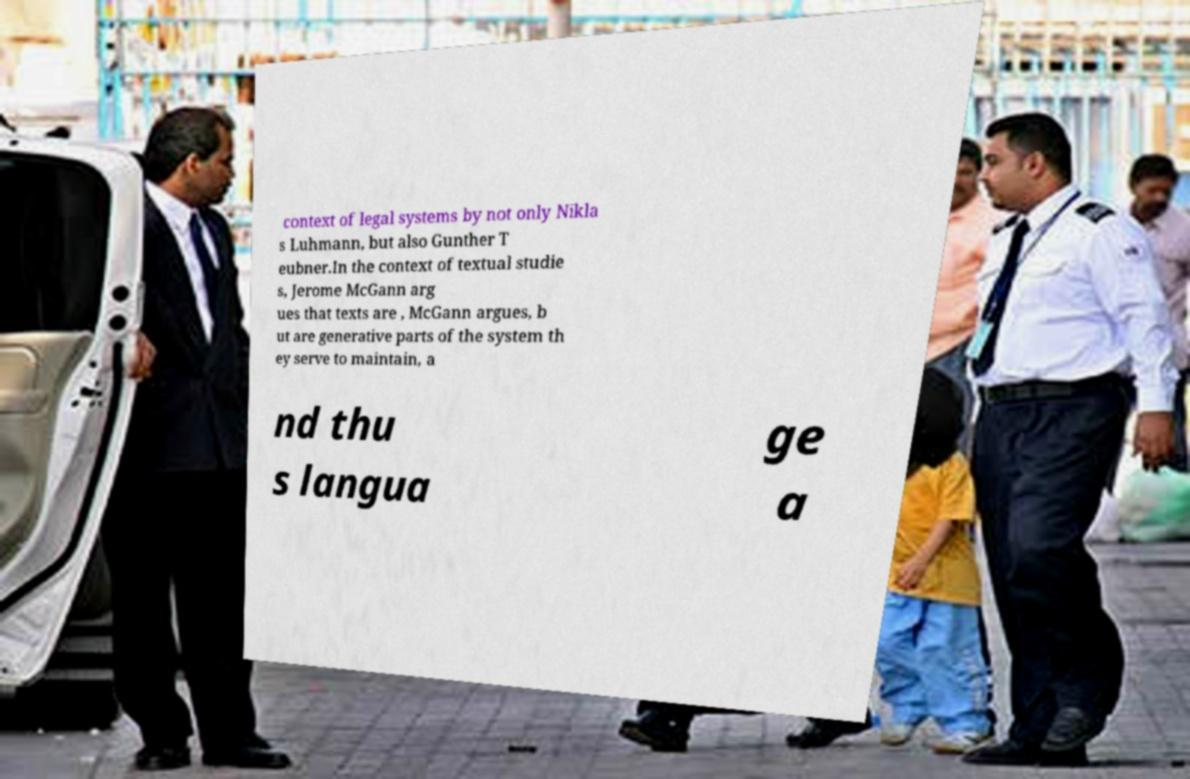Can you read and provide the text displayed in the image?This photo seems to have some interesting text. Can you extract and type it out for me? context of legal systems by not only Nikla s Luhmann, but also Gunther T eubner.In the context of textual studie s, Jerome McGann arg ues that texts are , McGann argues, b ut are generative parts of the system th ey serve to maintain, a nd thu s langua ge a 